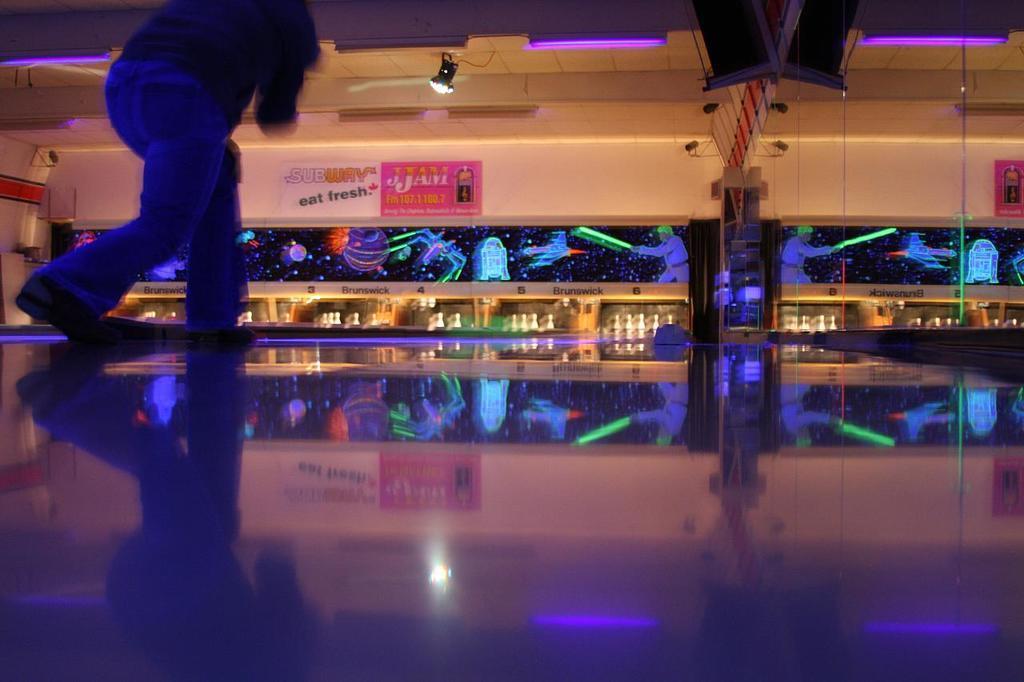In one or two sentences, can you explain what this image depicts? In this picture there is a man who is wearing t-shirt, jeans and shoes. He is a playing a bowling. In the bank I can see many pins on this box. At the top i can see the focus lights and television screen. In the center there is a poster on the wall. 